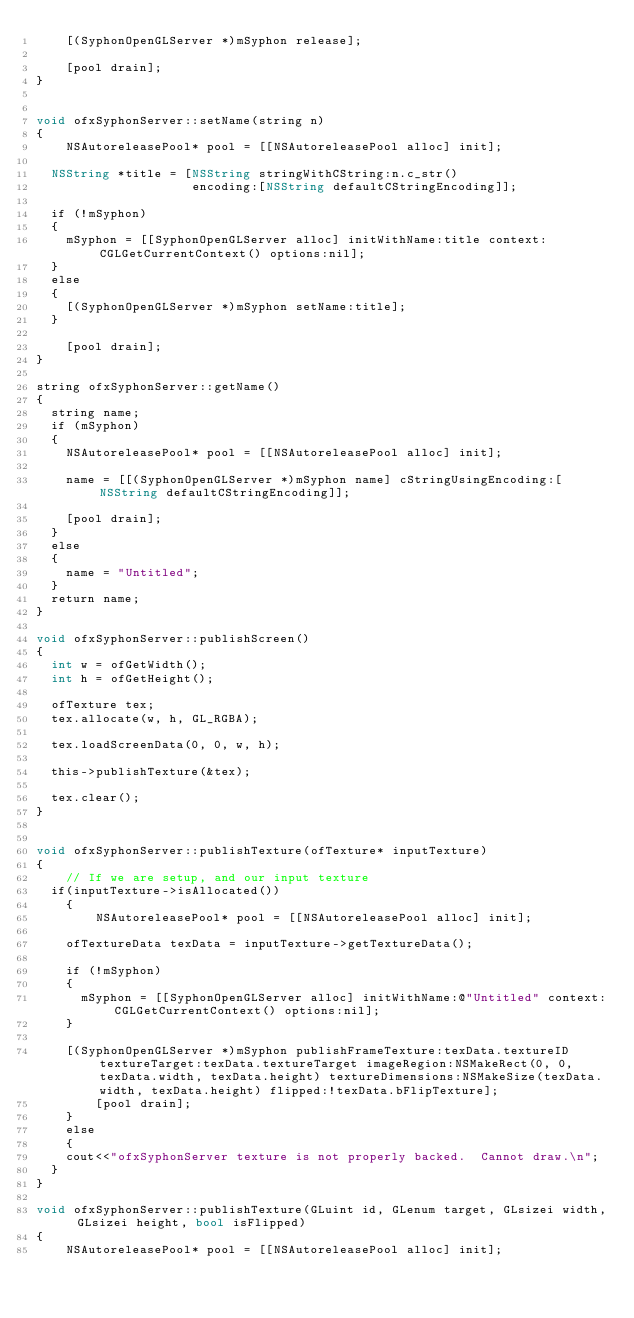Convert code to text. <code><loc_0><loc_0><loc_500><loc_500><_ObjectiveC_>    [(SyphonOpenGLServer *)mSyphon release];
    
    [pool drain];
}


void ofxSyphonServer::setName(string n)
{
    NSAutoreleasePool* pool = [[NSAutoreleasePool alloc] init];
    
	NSString *title = [NSString stringWithCString:n.c_str()
										 encoding:[NSString defaultCStringEncoding]];
	
	if (!mSyphon)
	{
		mSyphon = [[SyphonOpenGLServer alloc] initWithName:title context:CGLGetCurrentContext() options:nil];
	}
	else
	{
		[(SyphonOpenGLServer *)mSyphon setName:title];
	}
    
    [pool drain];
}

string ofxSyphonServer::getName()
{
	string name;
	if (mSyphon)
	{
		NSAutoreleasePool* pool = [[NSAutoreleasePool alloc] init];
        
		name = [[(SyphonOpenGLServer *)mSyphon name] cStringUsingEncoding:[NSString defaultCStringEncoding]];
		
		[pool drain];
	}
	else
	{
		name = "Untitled";
	}
	return name;
}

void ofxSyphonServer::publishScreen()
{
	int w = ofGetWidth();
	int h = ofGetHeight();
	
	ofTexture tex;
	tex.allocate(w, h, GL_RGBA);
	
	tex.loadScreenData(0, 0, w, h);
    
	this->publishTexture(&tex);
	
	tex.clear();
}


void ofxSyphonServer::publishTexture(ofTexture* inputTexture)
{
    // If we are setup, and our input texture
	if(inputTexture->isAllocated())
    {
        NSAutoreleasePool* pool = [[NSAutoreleasePool alloc] init];
        
		ofTextureData texData = inputTexture->getTextureData();
        
		if (!mSyphon)
		{
			mSyphon = [[SyphonOpenGLServer alloc] initWithName:@"Untitled" context:CGLGetCurrentContext() options:nil];
		}
		
		[(SyphonOpenGLServer *)mSyphon publishFrameTexture:texData.textureID textureTarget:texData.textureTarget imageRegion:NSMakeRect(0, 0, texData.width, texData.height) textureDimensions:NSMakeSize(texData.width, texData.height) flipped:!texData.bFlipTexture];
        [pool drain];
    }
    else
    {
		cout<<"ofxSyphonServer texture is not properly backed.  Cannot draw.\n";
	}
}

void ofxSyphonServer::publishTexture(GLuint id, GLenum target, GLsizei width, GLsizei height, bool isFlipped)
{
    NSAutoreleasePool* pool = [[NSAutoreleasePool alloc] init];
    </code> 